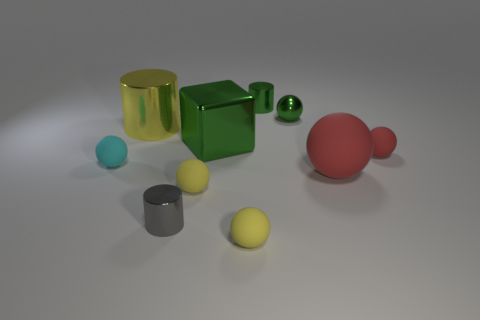Are there any shiny objects of the same shape as the big rubber object?
Give a very brief answer. Yes. There is a ball that is the same size as the block; what color is it?
Your answer should be compact. Red. What is the color of the tiny metal cylinder to the left of the tiny yellow object right of the big cube?
Offer a very short reply. Gray. Do the small metal cylinder behind the yellow metal object and the tiny shiny ball have the same color?
Give a very brief answer. Yes. There is a cyan thing behind the yellow sphere left of the tiny yellow matte ball that is in front of the tiny gray cylinder; what shape is it?
Provide a succinct answer. Sphere. What number of matte balls are to the right of the tiny yellow rubber object that is behind the gray metallic thing?
Ensure brevity in your answer.  3. Does the large yellow object have the same material as the small gray cylinder?
Provide a short and direct response. Yes. How many large objects are on the right side of the large thing to the left of the green metal object in front of the small green metal ball?
Your answer should be compact. 2. What is the color of the shiny cylinder to the left of the gray metal thing?
Your answer should be very brief. Yellow. There is a tiny green shiny object that is in front of the metallic cylinder that is behind the large metallic cylinder; what shape is it?
Give a very brief answer. Sphere. 